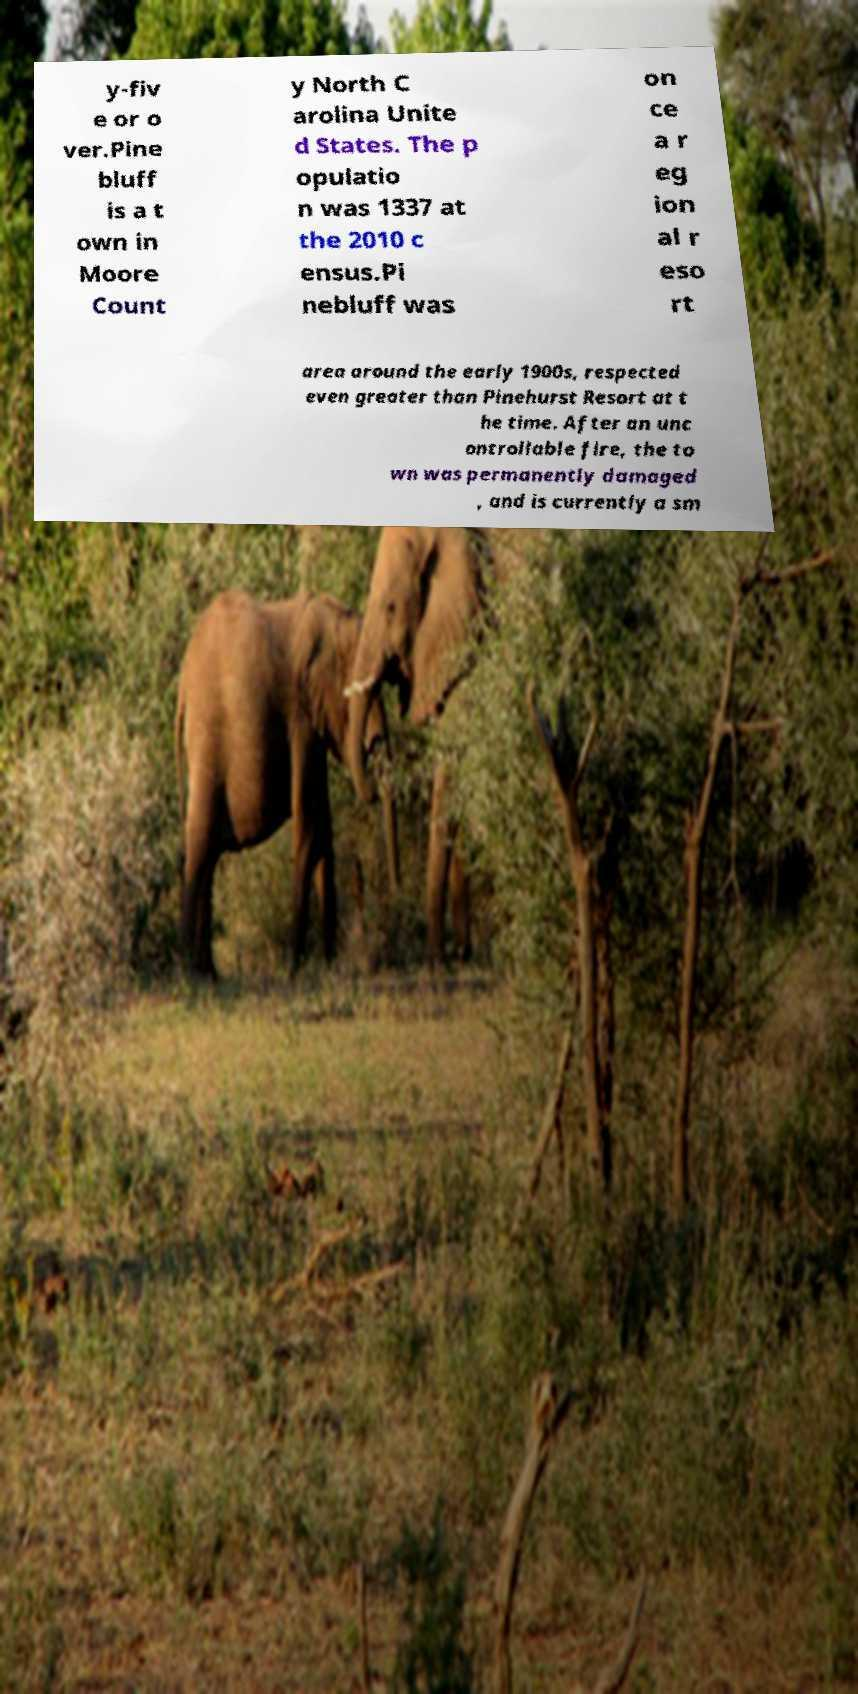Please read and relay the text visible in this image. What does it say? y-fiv e or o ver.Pine bluff is a t own in Moore Count y North C arolina Unite d States. The p opulatio n was 1337 at the 2010 c ensus.Pi nebluff was on ce a r eg ion al r eso rt area around the early 1900s, respected even greater than Pinehurst Resort at t he time. After an unc ontrollable fire, the to wn was permanently damaged , and is currently a sm 